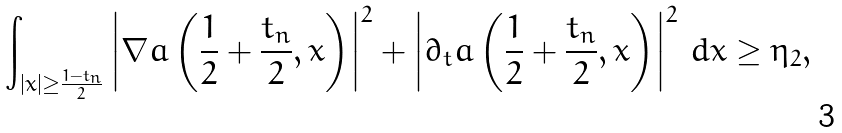<formula> <loc_0><loc_0><loc_500><loc_500>\int _ { | x | \geq \frac { 1 - t _ { n } } { 2 } } \left | \nabla a \left ( \frac { 1 } { 2 } + \frac { t _ { n } } { 2 } , x \right ) \right | ^ { 2 } + \left | \partial _ { t } a \left ( \frac { 1 } { 2 } + \frac { t _ { n } } { 2 } , x \right ) \right | ^ { 2 } \, d x \geq \eta _ { 2 } ,</formula> 